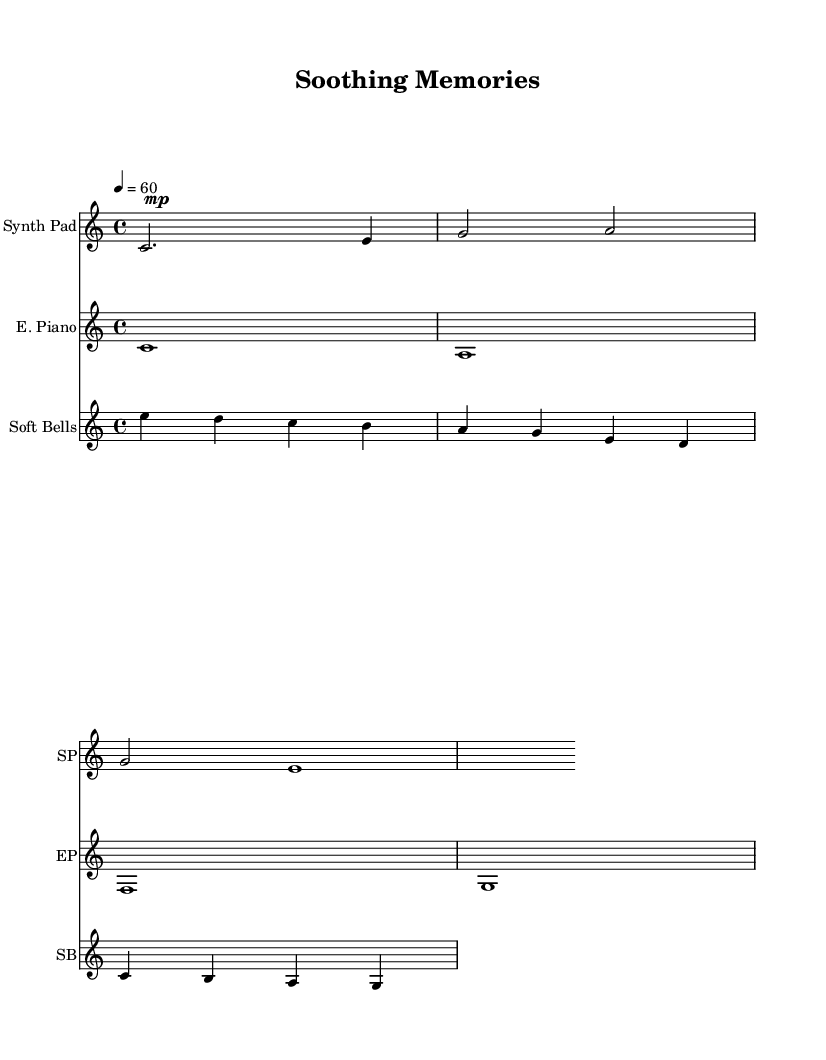What is the key signature of this music? The key signature is C major, which has no sharps or flats.
Answer: C major What is the time signature of this music? The time signature is found at the beginning of the score, indicating how many beats are in a measure and which note value gets the beat. It is 4/4, meaning there are 4 beats per measure and the quarter note receives one beat.
Answer: 4/4 What is the tempo marking for this piece? The tempo marking is specified in beats per minute (BPM), which indicates the speed of the music. Here, the tempo is marked as 4 = 60, suggesting that there are 60 beats in one minute at quarter note speed.
Answer: 60 How many instruments are featured in this score? To find the number of instruments, count the distinct staves in the score. There are three different staves representing the Synth Pad, Electric Piano, and Soft Bells, respectively.
Answer: 3 Which instrument plays the longest note in the first measure? By examining the first measure of each staff, we see that the Synth Pad has a half note (c2) while the others have shorter note values (e.g., quarter and eighth notes). Hence, the Synth Pad plays the longest note in the first measure.
Answer: Synth Pad What is the lowest note played in this piece? To determine the lowest note, inspect all staves and identify the vertical notation of pitches. The lowest note is played by the Electric Piano, which has an A note that is lower than any other notes in the piece.
Answer: A 